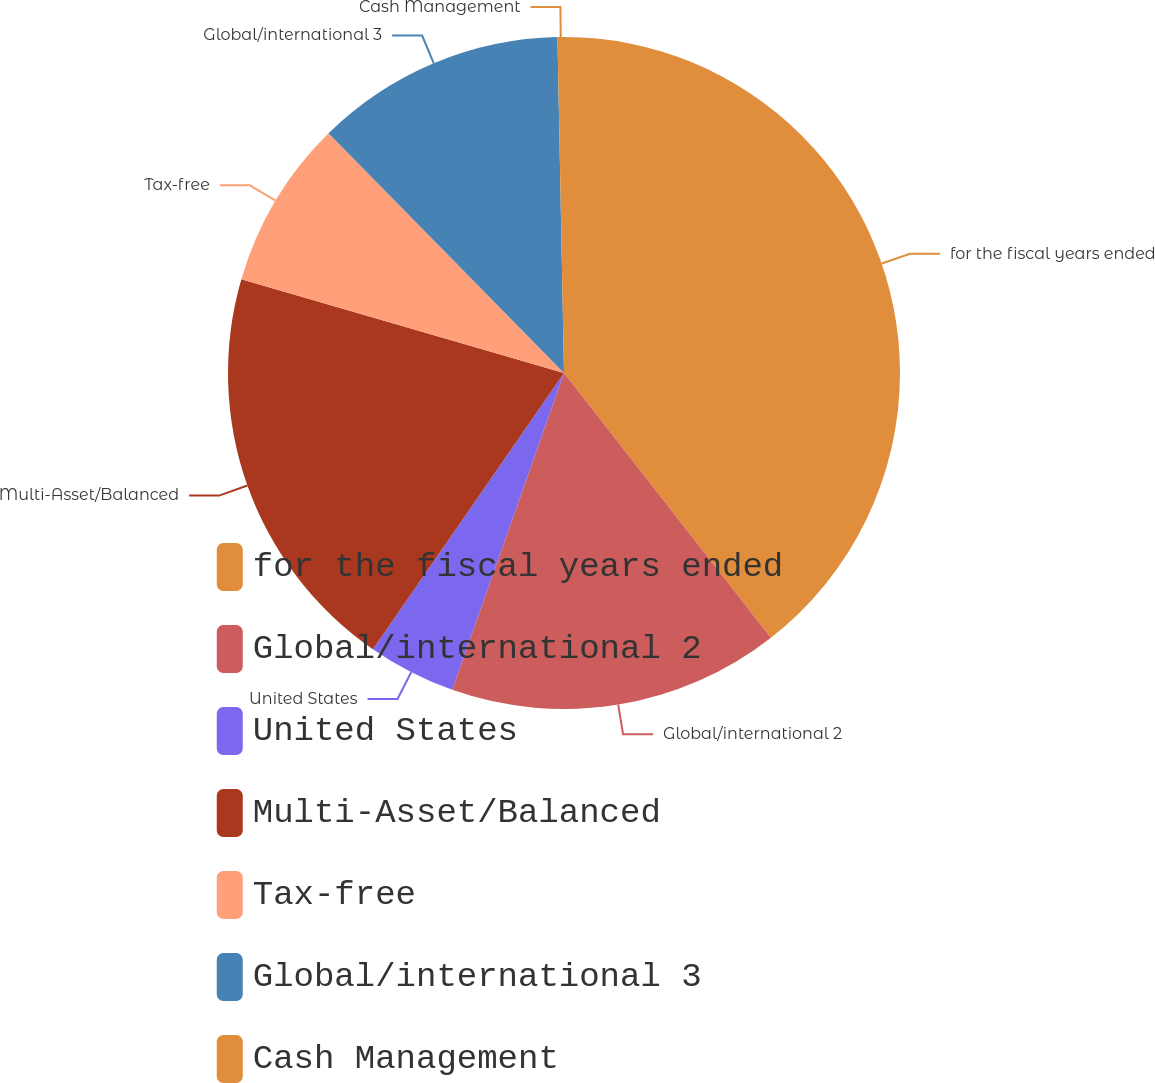Convert chart. <chart><loc_0><loc_0><loc_500><loc_500><pie_chart><fcel>for the fiscal years ended<fcel>Global/international 2<fcel>United States<fcel>Multi-Asset/Balanced<fcel>Tax-free<fcel>Global/international 3<fcel>Cash Management<nl><fcel>39.44%<fcel>15.96%<fcel>4.23%<fcel>19.87%<fcel>8.14%<fcel>12.05%<fcel>0.31%<nl></chart> 